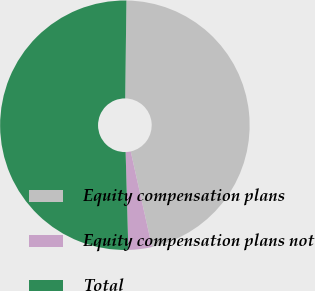Convert chart to OTSL. <chart><loc_0><loc_0><loc_500><loc_500><pie_chart><fcel>Equity compensation plans<fcel>Equity compensation plans not<fcel>Total<nl><fcel>46.31%<fcel>3.05%<fcel>50.64%<nl></chart> 